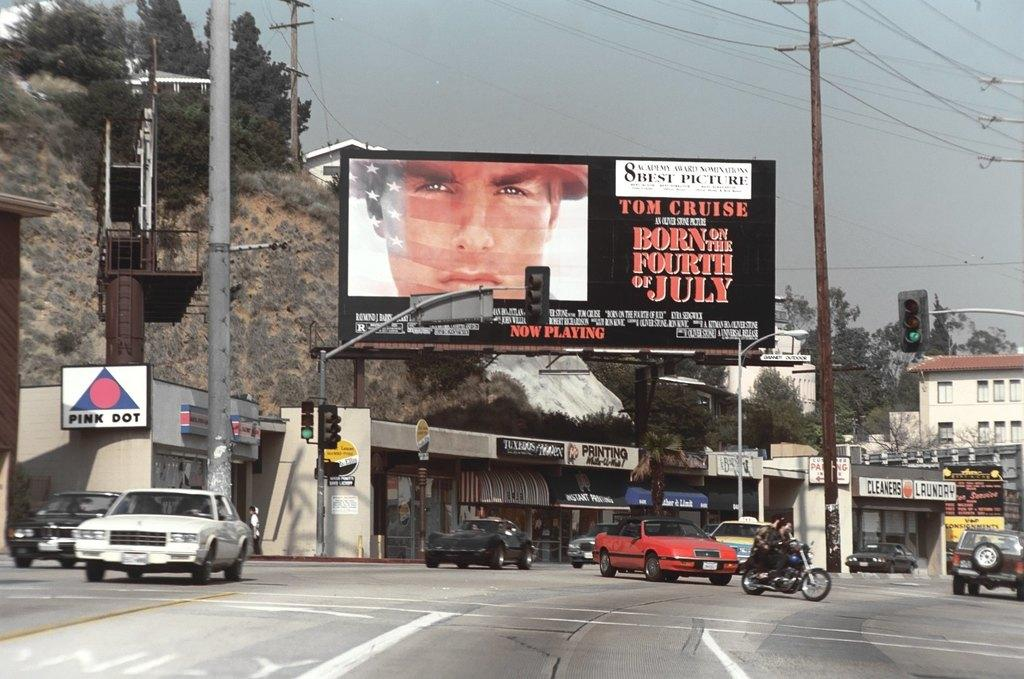<image>
Offer a succinct explanation of the picture presented. Born on the 4th of July is on a billboard above a street. 